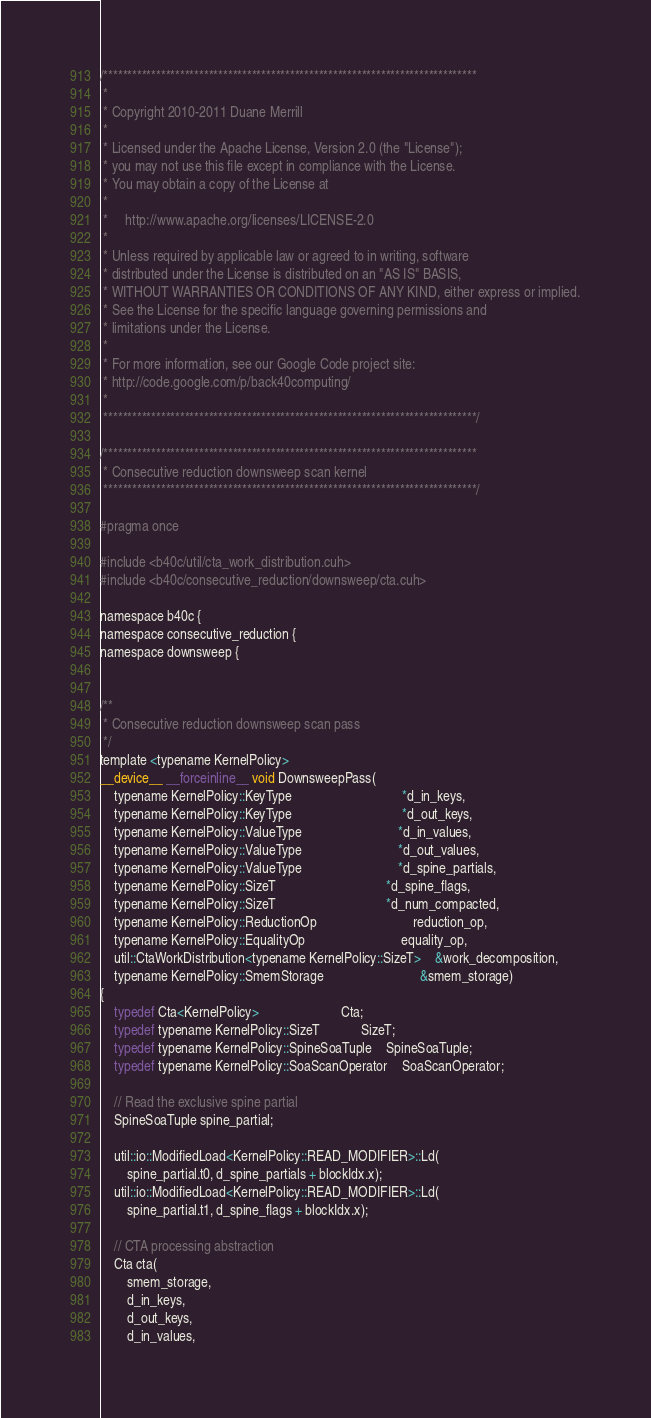<code> <loc_0><loc_0><loc_500><loc_500><_Cuda_>/******************************************************************************
 * 
 * Copyright 2010-2011 Duane Merrill
 * 
 * Licensed under the Apache License, Version 2.0 (the "License");
 * you may not use this file except in compliance with the License.
 * You may obtain a copy of the License at
 * 
 *     http://www.apache.org/licenses/LICENSE-2.0
 *
 * Unless required by applicable law or agreed to in writing, software
 * distributed under the License is distributed on an "AS IS" BASIS,
 * WITHOUT WARRANTIES OR CONDITIONS OF ANY KIND, either express or implied.
 * See the License for the specific language governing permissions and
 * limitations under the License. 
 * 
 * For more information, see our Google Code project site: 
 * http://code.google.com/p/back40computing/
 * 
 ******************************************************************************/

/******************************************************************************
 * Consecutive reduction downsweep scan kernel
 ******************************************************************************/

#pragma once

#include <b40c/util/cta_work_distribution.cuh>
#include <b40c/consecutive_reduction/downsweep/cta.cuh>

namespace b40c {
namespace consecutive_reduction {
namespace downsweep {


/**
 * Consecutive reduction downsweep scan pass
 */
template <typename KernelPolicy>
__device__ __forceinline__ void DownsweepPass(
	typename KernelPolicy::KeyType 								*d_in_keys,
	typename KernelPolicy::KeyType								*d_out_keys,
	typename KernelPolicy::ValueType 							*d_in_values,
	typename KernelPolicy::ValueType 							*d_out_values,
	typename KernelPolicy::ValueType 							*d_spine_partials,
	typename KernelPolicy::SizeT 								*d_spine_flags,
	typename KernelPolicy::SizeT								*d_num_compacted,
	typename KernelPolicy::ReductionOp 							reduction_op,
	typename KernelPolicy::EqualityOp							equality_op,
	util::CtaWorkDistribution<typename KernelPolicy::SizeT> 	&work_decomposition,
	typename KernelPolicy::SmemStorage							&smem_storage)
{
	typedef Cta<KernelPolicy> 						Cta;
	typedef typename KernelPolicy::SizeT 			SizeT;
	typedef typename KernelPolicy::SpineSoaTuple	SpineSoaTuple;
	typedef typename KernelPolicy::SoaScanOperator	SoaScanOperator;

	// Read the exclusive spine partial
	SpineSoaTuple spine_partial;

	util::io::ModifiedLoad<KernelPolicy::READ_MODIFIER>::Ld(
		spine_partial.t0, d_spine_partials + blockIdx.x);
	util::io::ModifiedLoad<KernelPolicy::READ_MODIFIER>::Ld(
		spine_partial.t1, d_spine_flags + blockIdx.x);

	// CTA processing abstraction
	Cta cta(
		smem_storage,
		d_in_keys,
		d_out_keys,
		d_in_values,</code> 